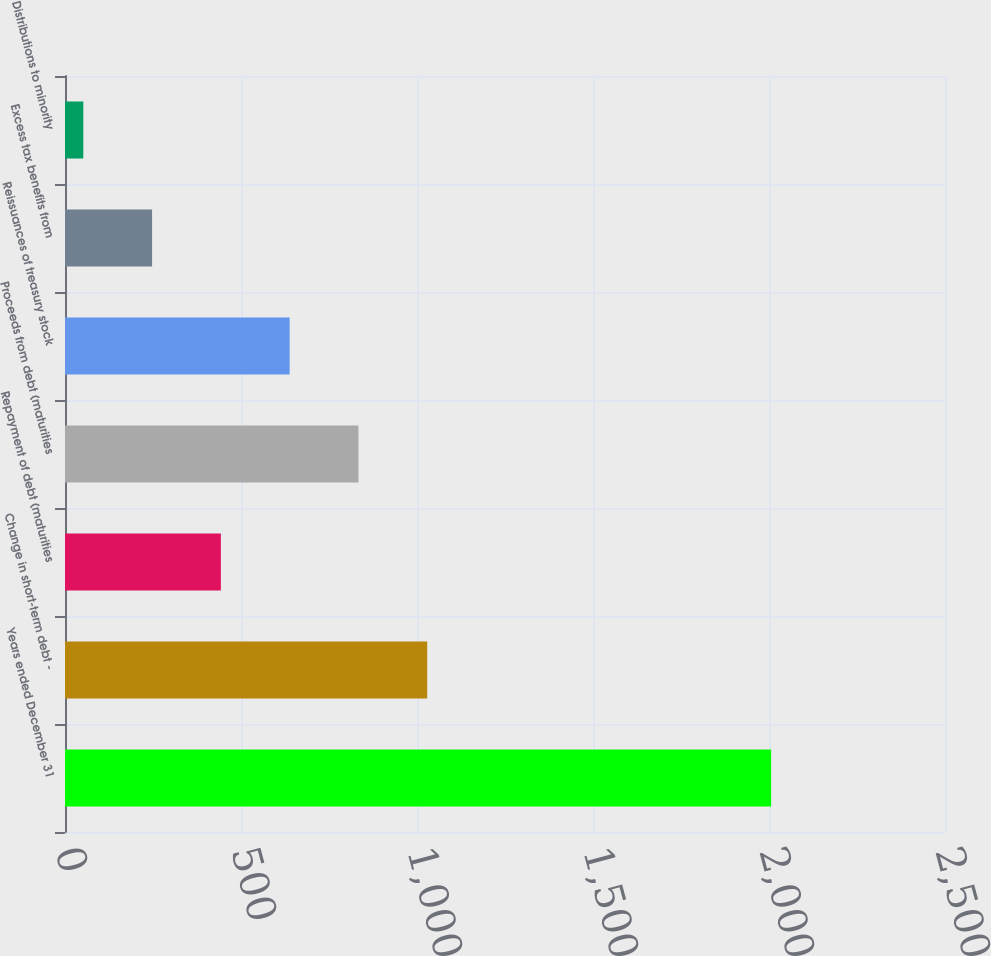Convert chart to OTSL. <chart><loc_0><loc_0><loc_500><loc_500><bar_chart><fcel>Years ended December 31<fcel>Change in short-term debt -<fcel>Repayment of debt (maturities<fcel>Proceeds from debt (maturities<fcel>Reissuances of treasury stock<fcel>Excess tax benefits from<fcel>Distributions to minority<nl><fcel>2006<fcel>1029<fcel>442.8<fcel>833.6<fcel>638.2<fcel>247.4<fcel>52<nl></chart> 